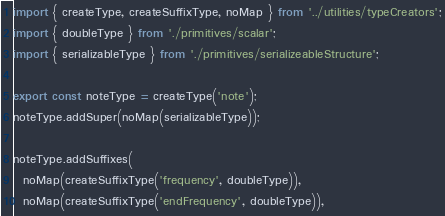Convert code to text. <code><loc_0><loc_0><loc_500><loc_500><_TypeScript_>import { createType, createSuffixType, noMap } from '../utilities/typeCreators';
import { doubleType } from './primitives/scalar';
import { serializableType } from './primitives/serializeableStructure';

export const noteType = createType('note');
noteType.addSuper(noMap(serializableType));

noteType.addSuffixes(
  noMap(createSuffixType('frequency', doubleType)),
  noMap(createSuffixType('endFrequency', doubleType)),</code> 